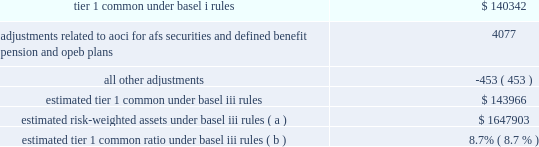Jpmorgan chase & co./2012 annual report 119 implementing further revisions to the capital accord in the u.s .
( such further revisions are commonly referred to as 201cbasel iii 201d ) .
Basel iii revised basel ii by , among other things , narrowing the definition of capital , and increasing capital requirements for specific exposures .
Basel iii also includes higher capital ratio requirements and provides that the tier 1 common capital requirement will be increased to 7% ( 7 % ) , comprised of a minimum ratio of 4.5% ( 4.5 % ) plus a 2.5% ( 2.5 % ) capital conservation buffer .
Implementation of the 7% ( 7 % ) tier 1 common capital requirement is required by january 1 , in addition , global systemically important banks ( 201cgsibs 201d ) will be required to maintain tier 1 common requirements above the 7% ( 7 % ) minimum in amounts ranging from an additional 1% ( 1 % ) to an additional 2.5% ( 2.5 % ) .
In november 2012 , the financial stability board ( 201cfsb 201d ) indicated that it would require the firm , as well as three other banks , to hold the additional 2.5% ( 2.5 % ) of tier 1 common ; the requirement will be phased in beginning in 2016 .
The basel committee also stated it intended to require certain gsibs to hold an additional 1% ( 1 % ) of tier 1 common under certain circumstances , to act as a disincentive for the gsib from taking actions that would further increase its systemic importance .
Currently , no gsib ( including the firm ) is required to hold this additional 1% ( 1 % ) of tier 1 common .
In addition , pursuant to the requirements of the dodd-frank act , u.s .
Federal banking agencies have proposed certain permanent basel i floors under basel ii and basel iii capital calculations .
The table presents a comparison of the firm 2019s tier 1 common under basel i rules to its estimated tier 1 common under basel iii rules , along with the firm 2019s estimated risk-weighted assets .
Tier 1 common under basel iii includes additional adjustments and deductions not included in basel i tier 1 common , such as the inclusion of aoci related to afs securities and defined benefit pension and other postretirement employee benefit ( 201copeb 201d ) plans .
The firm estimates that its tier 1 common ratio under basel iii rules would be 8.7% ( 8.7 % ) as of december 31 , 2012 .
The tier 1 common ratio under both basel i and basel iii are non- gaap financial measures .
However , such measures are used by bank regulators , investors and analysts as a key measure to assess the firm 2019s capital position and to compare the firm 2019s capital to that of other financial services companies .
December 31 , 2012 ( in millions , except ratios ) .
Estimated risk-weighted assets under basel iii rules ( a ) $ 1647903 estimated tier 1 common ratio under basel iii rules ( b ) 8.7% ( 8.7 % ) ( a ) key differences in the calculation of risk-weighted assets between basel i and basel iii include : ( 1 ) basel iii credit risk rwa is based on risk-sensitive approaches which largely rely on the use of internal credit models and parameters , whereas basel i rwa is based on fixed supervisory risk weightings which vary only by counterparty type and asset class ; ( 2 ) basel iii market risk rwa reflects the new capital requirements related to trading assets and securitizations , which include incremental capital requirements for stress var , correlation trading , and re-securitization positions ; and ( 3 ) basel iii includes rwa for operational risk , whereas basel i does not .
The actual impact on the firm 2019s capital ratios upon implementation could differ depending on final implementation guidance from the regulators , as well as regulatory approval of certain of the firm 2019s internal risk models .
( b ) the tier 1 common ratio is tier 1 common divided by rwa .
The firm 2019s estimate of its tier 1 common ratio under basel iii reflects its current understanding of the basel iii rules based on information currently published by the basel committee and u.s .
Federal banking agencies and on the application of such rules to its businesses as currently conducted ; it excludes the impact of any changes the firm may make in the future to its businesses as a result of implementing the basel iii rules , possible enhancements to certain market risk models , and any further implementation guidance from the regulators .
The basel iii capital requirements are subject to prolonged transition periods .
The transition period for banks to meet the tier 1 common requirement under basel iii was originally scheduled to begin in 2013 , with full implementation on january 1 , 2019 .
In november 2012 , the u.s .
Federal banking agencies announced a delay in the implementation dates for the basel iii capital requirements .
The additional capital requirements for gsibs will be phased in starting january 1 , 2016 , with full implementation on january 1 , 2019 .
Management 2019s current objective is for the firm to reach , by the end of 2013 , an estimated basel iii tier i common ratio of 9.5% ( 9.5 % ) .
Additional information regarding the firm 2019s capital ratios and the federal regulatory capital standards to which it is subject is presented in supervision and regulation on pages 1 20138 of the 2012 form 10-k , and note 28 on pages 306 2013 308 of this annual report .
Broker-dealer regulatory capital jpmorgan chase 2019s principal u.s .
Broker-dealer subsidiaries are j.p .
Morgan securities llc ( 201cjpmorgan securities 201d ) and j.p .
Morgan clearing corp .
( 201cjpmorgan clearing 201d ) .
Jpmorgan clearing is a subsidiary of jpmorgan securities and provides clearing and settlement services .
Jpmorgan securities and jpmorgan clearing are each subject to rule 15c3-1 under the securities exchange act of 1934 ( the 201cnet capital rule 201d ) .
Jpmorgan securities and jpmorgan clearing are also each registered as futures commission merchants and subject to rule 1.17 of the commodity futures trading commission ( 201ccftc 201d ) .
Jpmorgan securities and jpmorgan clearing have elected to compute their minimum net capital requirements in accordance with the 201calternative net capital requirements 201d of the net capital rule .
At december 31 , 2012 , jpmorgan securities 2019 net capital , as defined by the net capital rule , was $ 13.5 billion , exceeding the minimum requirement by .
As of the current year , did the firm meet the eventual objective of an estimated basel iii tier i common ratio of 9.5%? 
Computations: (8.7 > 9.5)
Answer: no. 